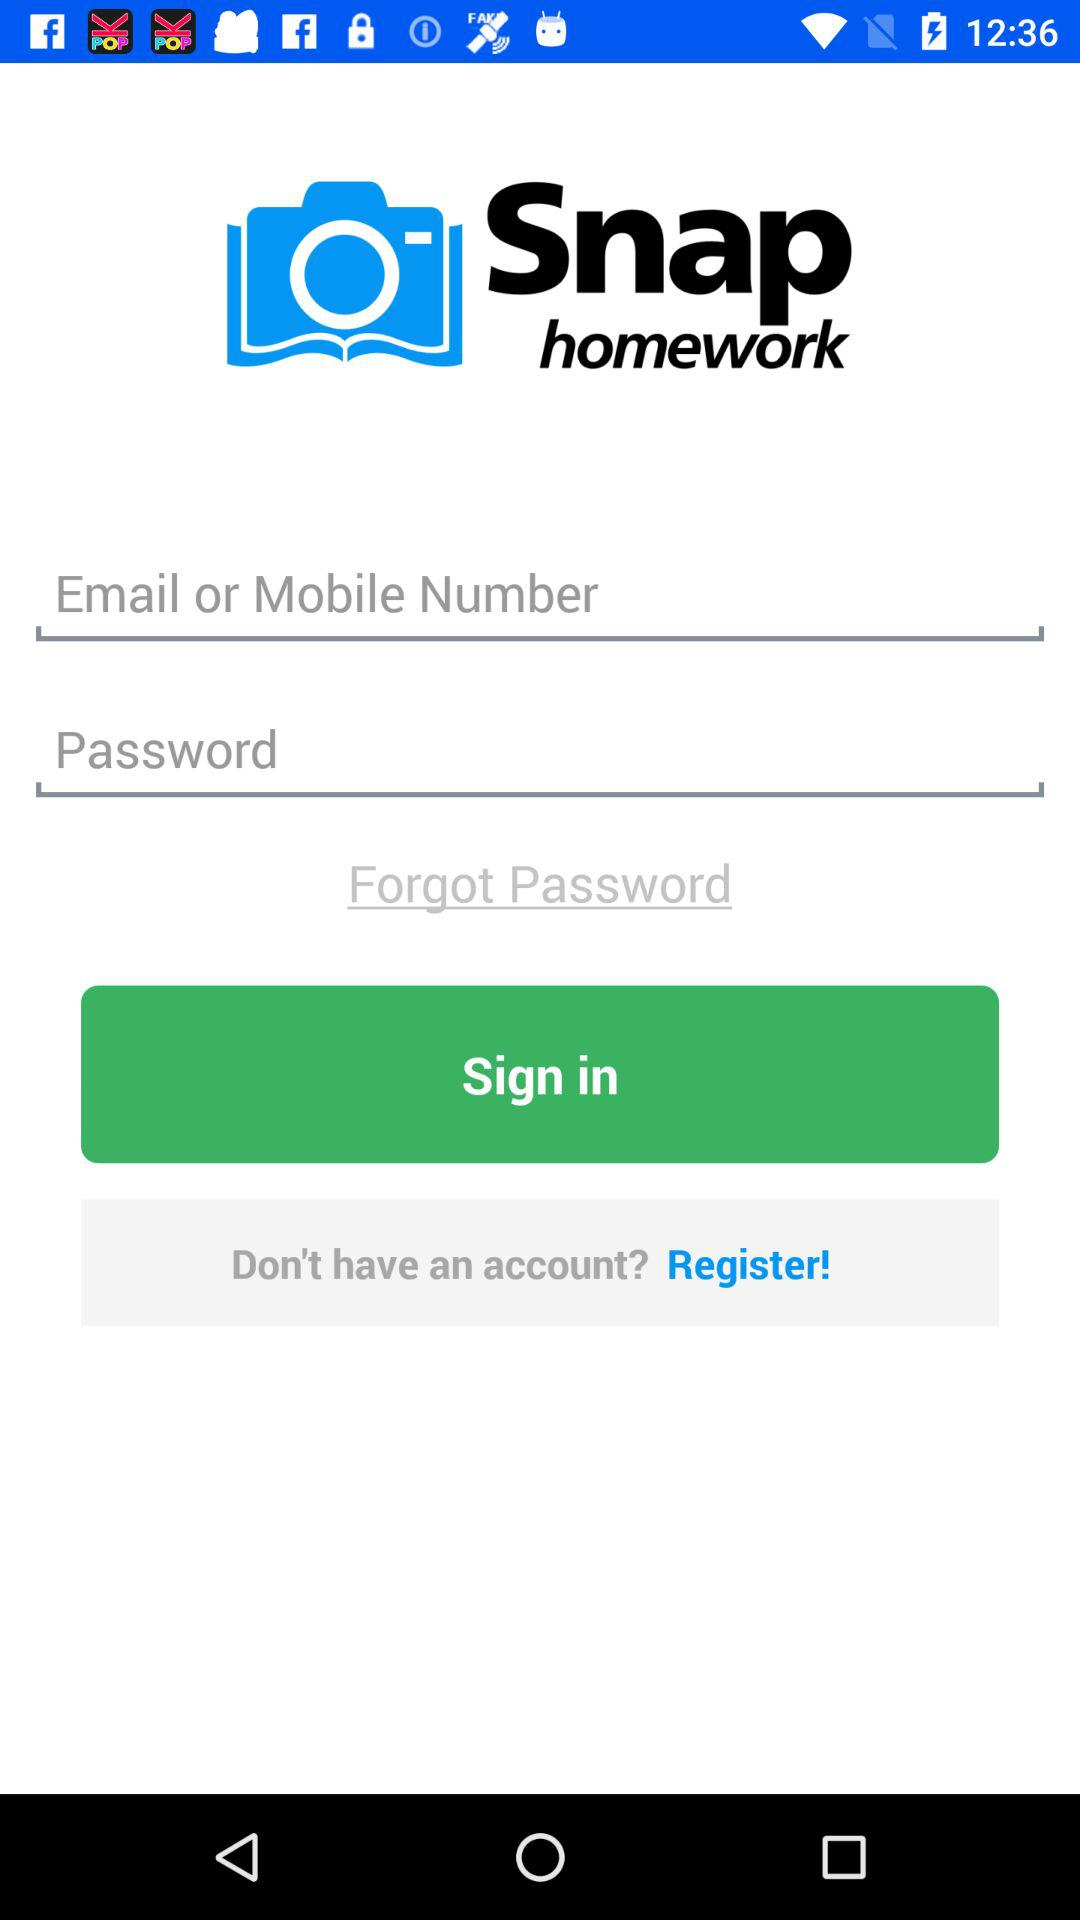What application is used on the screen? The application used on the screen is "Snap homework". 